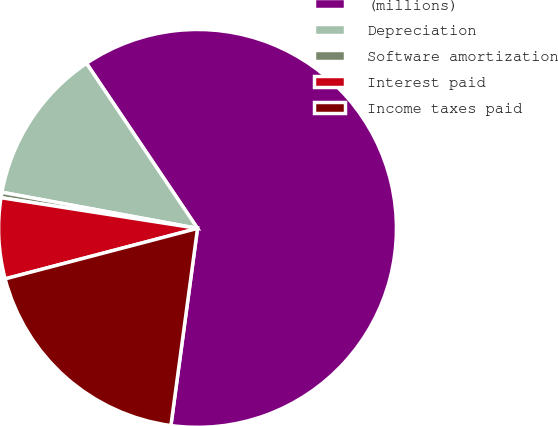<chart> <loc_0><loc_0><loc_500><loc_500><pie_chart><fcel>(millions)<fcel>Depreciation<fcel>Software amortization<fcel>Interest paid<fcel>Income taxes paid<nl><fcel>61.56%<fcel>12.67%<fcel>0.44%<fcel>6.55%<fcel>18.78%<nl></chart> 